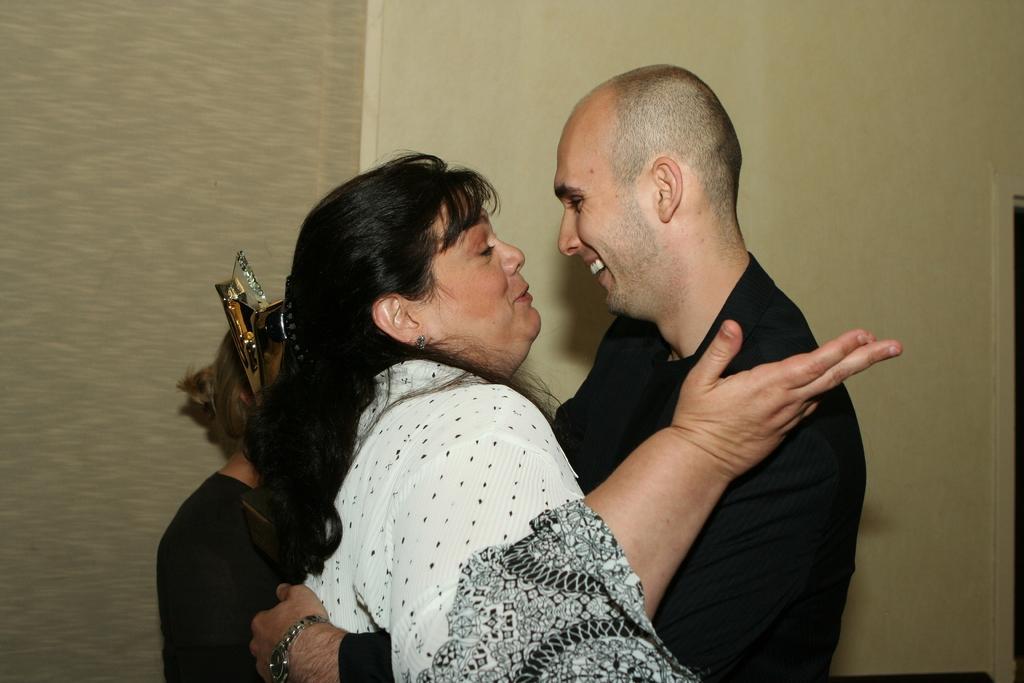Describe this image in one or two sentences. In this image I can see three people. I can see some object. In the background, I can see the wall. 